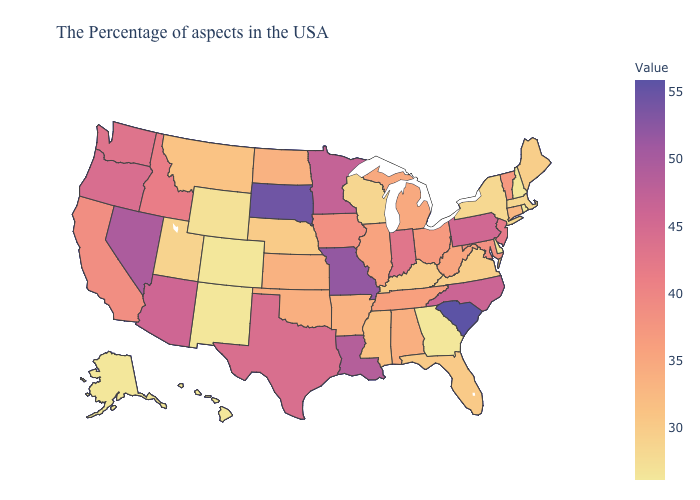Does Texas have the lowest value in the USA?
Give a very brief answer. No. Which states have the lowest value in the USA?
Keep it brief. Rhode Island, New Hampshire, Delaware, Georgia, Colorado, New Mexico, Alaska, Hawaii. Does New Hampshire have the highest value in the USA?
Concise answer only. No. Which states have the lowest value in the USA?
Quick response, please. Rhode Island, New Hampshire, Delaware, Georgia, Colorado, New Mexico, Alaska, Hawaii. Does Ohio have the highest value in the USA?
Answer briefly. No. Does Nevada have the highest value in the West?
Give a very brief answer. Yes. 